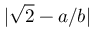Convert formula to latex. <formula><loc_0><loc_0><loc_500><loc_500>| { \sqrt { 2 } } - a / b |</formula> 